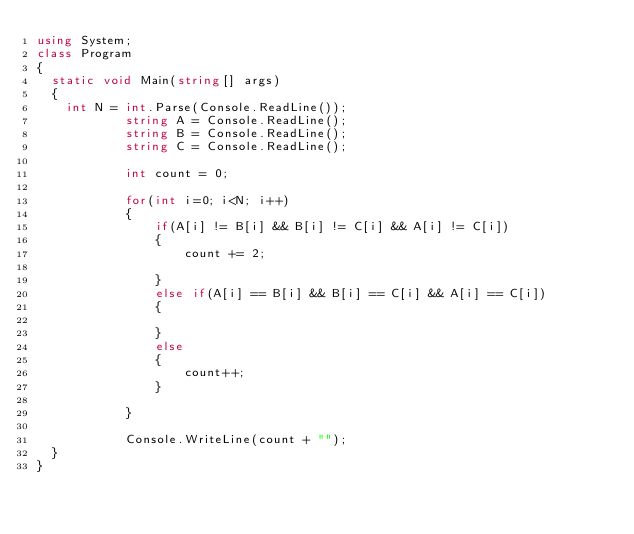Convert code to text. <code><loc_0><loc_0><loc_500><loc_500><_C#_>using System;
class Program
{
	static void Main(string[] args)
	{
		int N = int.Parse(Console.ReadLine());
            string A = Console.ReadLine();
            string B = Console.ReadLine();
            string C = Console.ReadLine();

            int count = 0;

            for(int i=0; i<N; i++)
            {
                if(A[i] != B[i] && B[i] != C[i] && A[i] != C[i])
                {
                    count += 2;
            
                }
                else if(A[i] == B[i] && B[i] == C[i] && A[i] == C[i])
                {

                }
                else
                {
                    count++;
                }

            }

            Console.WriteLine(count + "");
	}
}</code> 